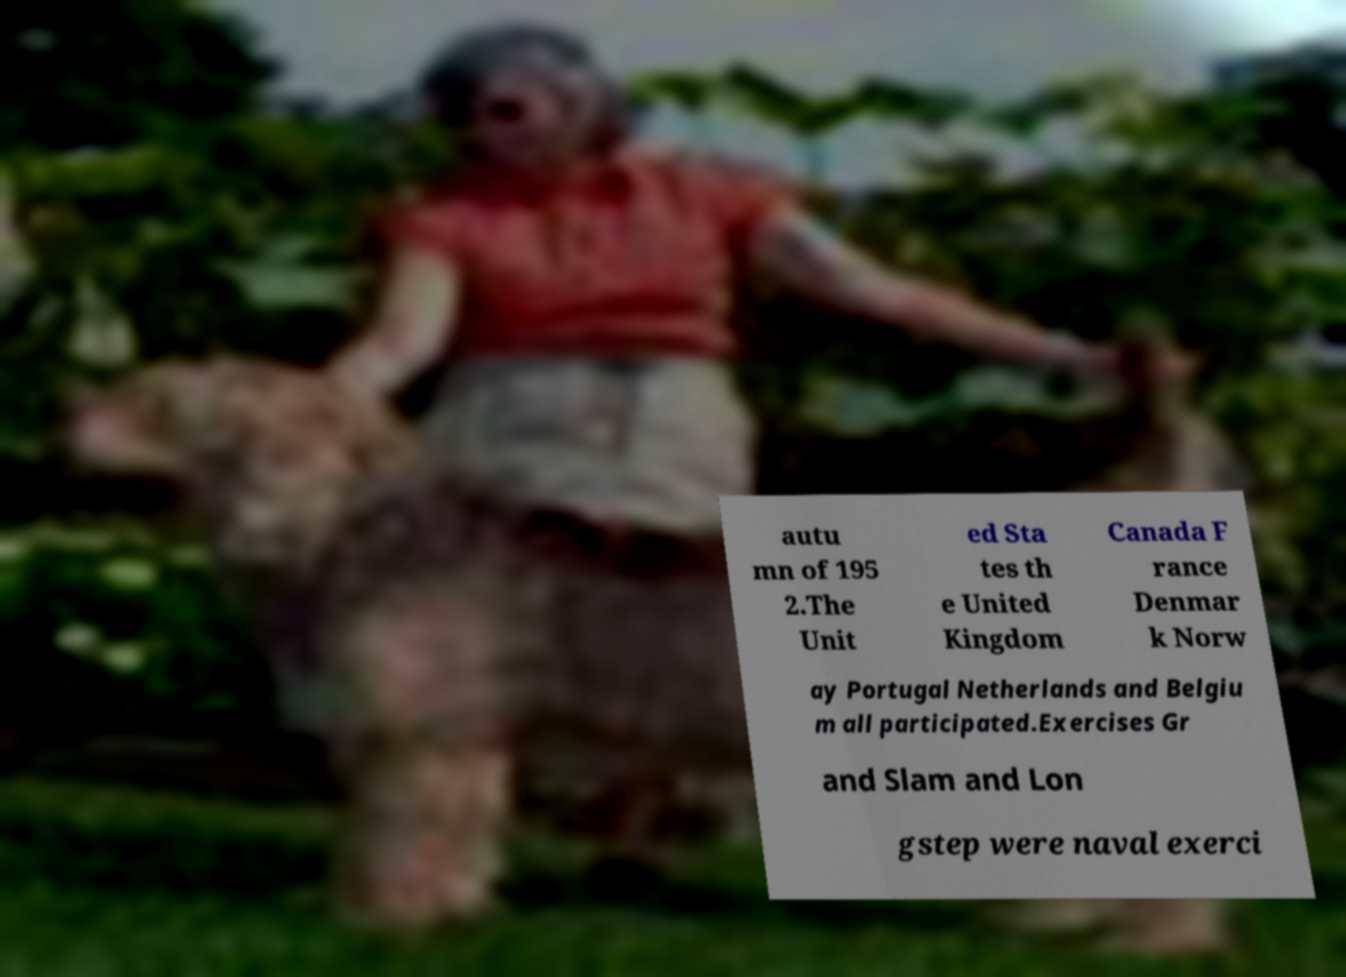Can you accurately transcribe the text from the provided image for me? autu mn of 195 2.The Unit ed Sta tes th e United Kingdom Canada F rance Denmar k Norw ay Portugal Netherlands and Belgiu m all participated.Exercises Gr and Slam and Lon gstep were naval exerci 